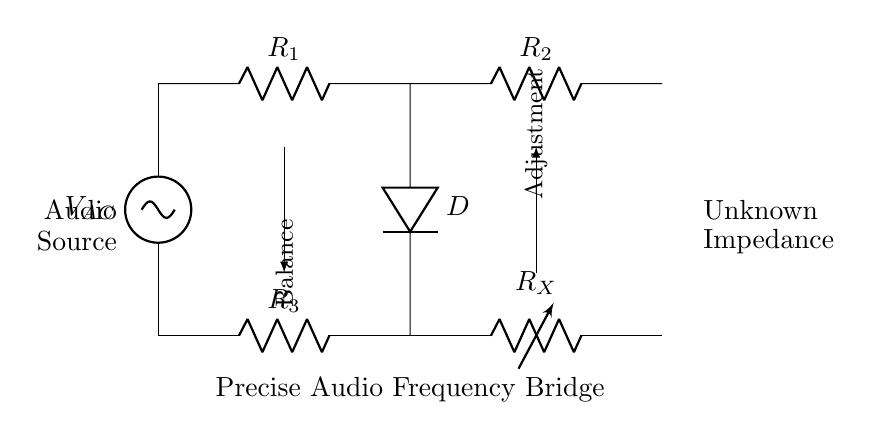What type of bridge is this circuit? The circuit is an AC bridge circuit, specifically designed for precise audio frequency measurements. It consists of resistive elements for balancing the circuit against an unknown impedance.
Answer: AC bridge What does the variable resistor represent in this circuit? The variable resistor, labeled as R_X, represents an unknown impedance that can be adjusted to achieve balance within the circuit, crucial for precise measurements.
Answer: Unknown impedance How many resistors are present in the circuit? There are four resistors (R_1, R_2, R_3, and R_X) visible in the bridge circuit diagram, contributing to the overall impedance.
Answer: Four What is the function of the detector labeled D in the circuit? The function of the detector D is to sense the balance condition of the bridge. When the bridge is balanced, the voltage across the detector becomes zero, indicating a precise measurement condition.
Answer: Balance detection What is the audio source labeled in the circuit? The audio source is labeled V_AC, which represents the alternating current input providing the necessary voltage for the operation of the bridge circuit.
Answer: V_AC What do the arrows signify in the circuit diagram? The arrows indicate the paths for achieving balance and adjustment. The first arrow denotes the balance condition while the second represents the adjustment needed to reach that balance in the circuit.
Answer: Balance adjustment What is the primary application of this AC bridge circuit? The primary application is for precise audio frequency measurements in recording studios, allowing for accurate calibration and impedance matching of audio equipment.
Answer: Audio frequency measurements 